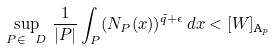<formula> <loc_0><loc_0><loc_500><loc_500>\sup _ { P \in \ D } \, \frac { 1 } { | P | } \int _ { P } ( { N } _ { P } ( x ) ) ^ { \tilde { q } + \epsilon } \, d x < [ W ] _ { \text {A} _ { p } }</formula> 